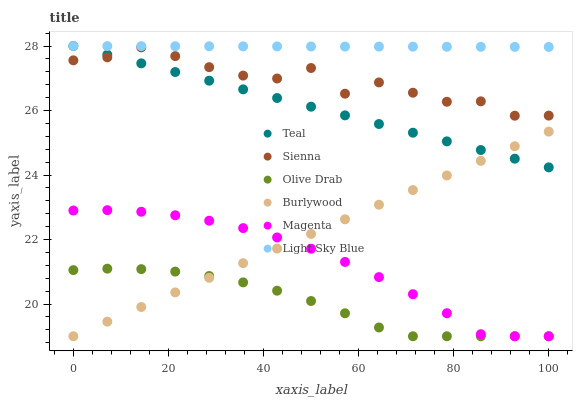Does Olive Drab have the minimum area under the curve?
Answer yes or no. Yes. Does Light Sky Blue have the maximum area under the curve?
Answer yes or no. Yes. Does Sienna have the minimum area under the curve?
Answer yes or no. No. Does Sienna have the maximum area under the curve?
Answer yes or no. No. Is Burlywood the smoothest?
Answer yes or no. Yes. Is Sienna the roughest?
Answer yes or no. Yes. Is Light Sky Blue the smoothest?
Answer yes or no. No. Is Light Sky Blue the roughest?
Answer yes or no. No. Does Burlywood have the lowest value?
Answer yes or no. Yes. Does Sienna have the lowest value?
Answer yes or no. No. Does Teal have the highest value?
Answer yes or no. Yes. Does Sienna have the highest value?
Answer yes or no. No. Is Olive Drab less than Light Sky Blue?
Answer yes or no. Yes. Is Sienna greater than Olive Drab?
Answer yes or no. Yes. Does Teal intersect Burlywood?
Answer yes or no. Yes. Is Teal less than Burlywood?
Answer yes or no. No. Is Teal greater than Burlywood?
Answer yes or no. No. Does Olive Drab intersect Light Sky Blue?
Answer yes or no. No. 